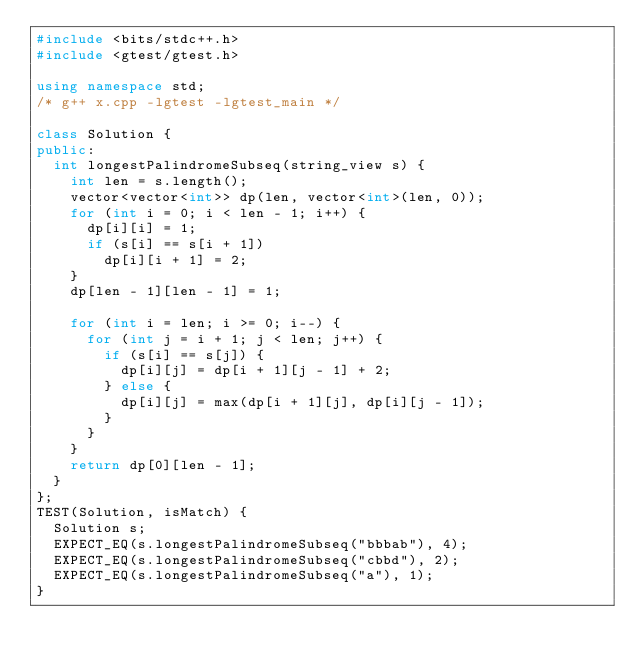<code> <loc_0><loc_0><loc_500><loc_500><_C++_>#include <bits/stdc++.h>
#include <gtest/gtest.h>

using namespace std;
/* g++ x.cpp -lgtest -lgtest_main */

class Solution {
public:
  int longestPalindromeSubseq(string_view s) {
    int len = s.length();
    vector<vector<int>> dp(len, vector<int>(len, 0));
    for (int i = 0; i < len - 1; i++) {
      dp[i][i] = 1;
      if (s[i] == s[i + 1])
        dp[i][i + 1] = 2;
    }
    dp[len - 1][len - 1] = 1;

    for (int i = len; i >= 0; i--) {
      for (int j = i + 1; j < len; j++) {
        if (s[i] == s[j]) {
          dp[i][j] = dp[i + 1][j - 1] + 2;
        } else {
          dp[i][j] = max(dp[i + 1][j], dp[i][j - 1]);
        }
      }
    }
    return dp[0][len - 1];
  }
};
TEST(Solution, isMatch) {
  Solution s;
  EXPECT_EQ(s.longestPalindromeSubseq("bbbab"), 4);
  EXPECT_EQ(s.longestPalindromeSubseq("cbbd"), 2);
  EXPECT_EQ(s.longestPalindromeSubseq("a"), 1);
}
</code> 